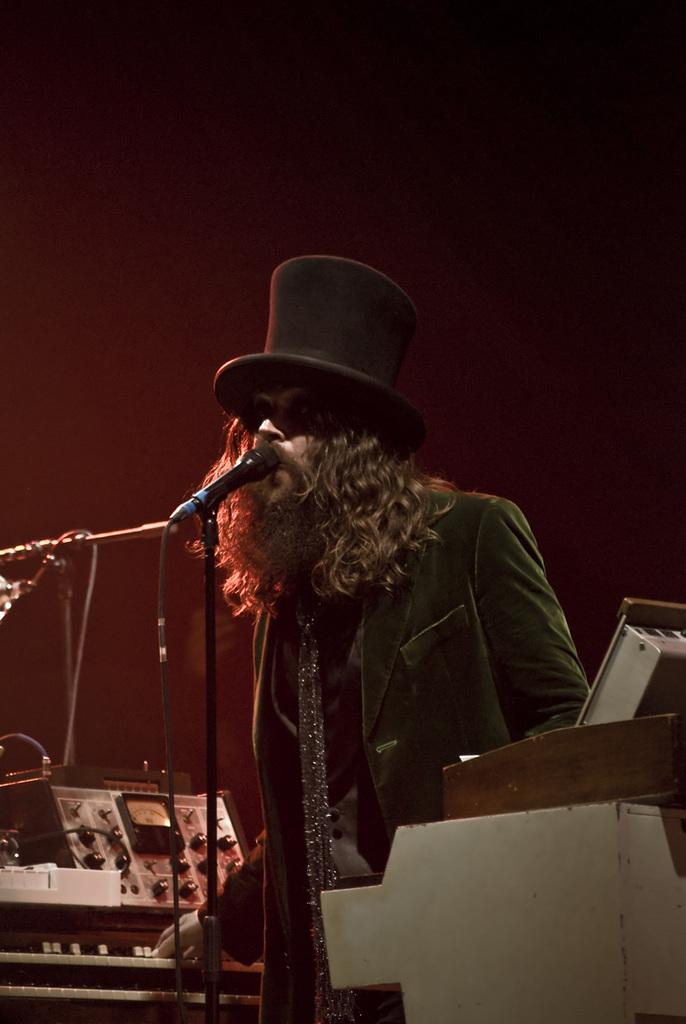What is the person in the image doing? The person is standing and singing in the image. What object is the person holding while singing? The person is holding a microphone. Are there any other musical elements in the image? Yes, there are musical instruments in the image. Is the person talking instead of singing in the image? No, the person is singing, not talking, in the image. What type of cable is connected to the microphone in the image? There is no cable connected to the microphone in the image. 